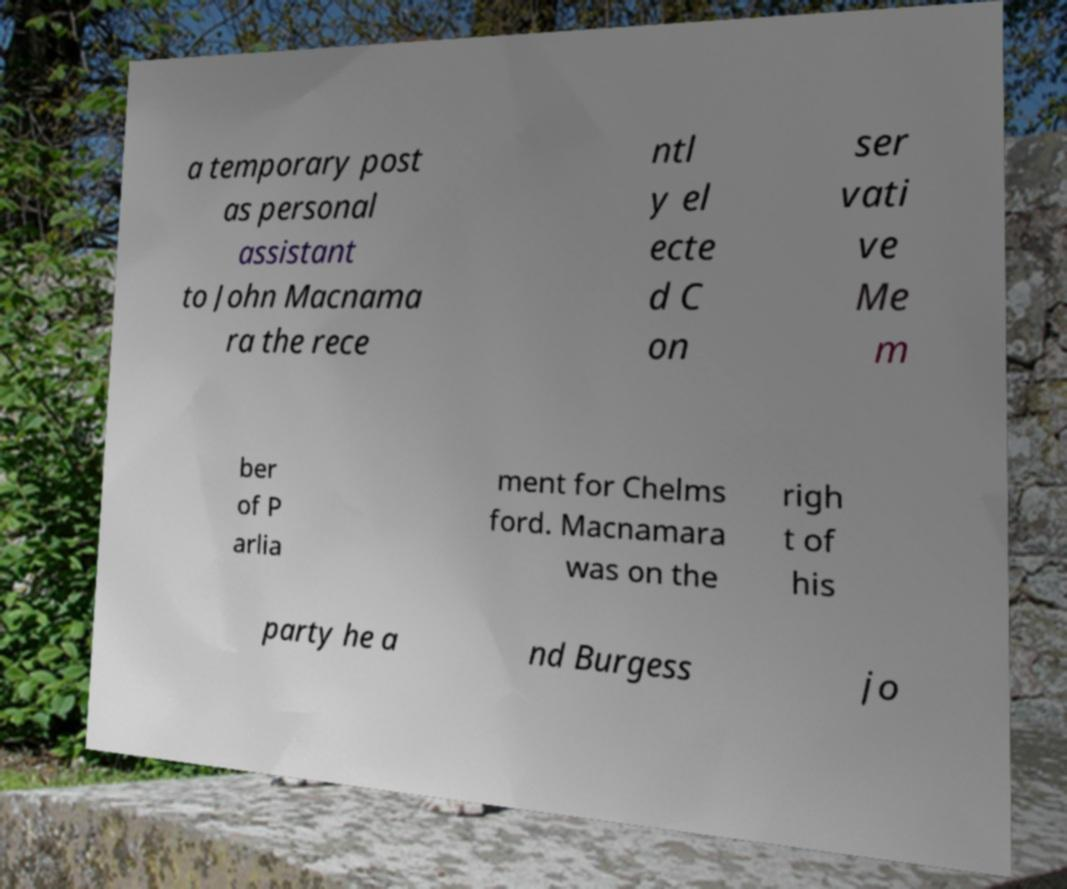I need the written content from this picture converted into text. Can you do that? a temporary post as personal assistant to John Macnama ra the rece ntl y el ecte d C on ser vati ve Me m ber of P arlia ment for Chelms ford. Macnamara was on the righ t of his party he a nd Burgess jo 